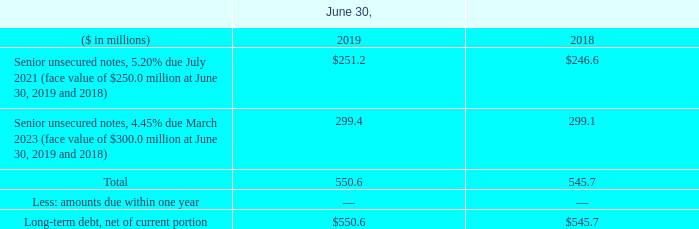10. Debt
On March 31, 2017, the Company entered into a
On March 31, 2017, the Company entered into a $400.0 million syndicated credit facility (“Credit Agreement”) that extends to March 2022. Interest on the borrowings under the Credit Agreement accrue at variable rates, based upon LIBOR or a defined “Base Rate,” both determined based upon the rating of the Company’s senior unsecured long-term debt (the “Debt Rating”). The applicable margin to be added to LIBOR ranges from 1.00% to 1.75% (1.25% as of June 30, 2019), and for Base Rate-determined loans, from 0.00% to 0.75% (0.25% as of June 30, 2019). The Company also pays a quarterly commitment fee ranging from 0.125% to 0.400% (0.20% as of June 30, 2019), determined based upon the Debt Rating, of the unused portion of the $400.0 million commitment under the Credit Agreement. In addition, the Company must pay certain letter of credit fees, ranging from 1.00% to 1.75% (1.25% as of June 30, 2019), with respect to letters of credit issued under the Credit Agreement. The Company has the right to voluntarily prepay and re-borrow loans and to terminate or reduce the commitments under the facility. As of June 30, 2019, the Company had $6.0 million of issued letters of credit under the Credit Agreement and $19.7 million of short-term borrowings, with the balance of $374.3 million available to the Company. As of June 30, 2019, the borrowing rate for the Credit Agreement was 3.90%.
The Company is subject to certain financial and restrictive covenants under the Credit Agreement, which, among other things, require the maintenance of a minimum interest coverage ratio of 3.50 to 1.00. The interest coverage ratio is defined in the Credit Agreement as, for any period, the ratio of consolidated earnings before interest, taxes, depreciation and amortization and non-cash net pension expense (“EBITDA”) to consolidated interest expense for such period. The Credit Agreement also requires the Company to maintain a debt to capital ratio of less than 55 percent. The debt to capital ratio is defined in the Credit Agreement as the ratio of consolidated indebtedness, as defined therein, to consolidated capitalization, as defined therein. As of June 30, 2019, the Company was in compliance with all of the covenants of the Credit Agreement.
Long-term debt outstanding as of June 30, 2019 and 2018 consisted of the following:
Aggregate maturities of long-term debt for the five years subsequent to June 30, 2019, are $0.0 million in fiscal years 2020, 2021, $250.0 million in 2022, $300.0 million in 2023 and $0.0 million in 2024.
For the years ended June 30, 2019, 2018 and 2017, interest costs totaled $31.1 million, $31.1 million and $31.1 million, respectively, of which $5.1 million, $2.8 million and $1.3 million, respectively, were capitalized as part of the cost of property, plant, equipment and software.
What were the interest costs in 2019? $31.1 million. How is the interest coverage ratio defined? The interest coverage ratio is defined in the credit agreement as, for any period, the ratio of consolidated earnings before interest, taxes, depreciation and amortization and non-cash net pension expense (“ebitda”) to consolidated interest expense for such period. In which years was the amount of long-term debt calculated? 2019, 2018. In which year was Total debt larger? 550.6>545.7
Answer: 2019. What was the change in Total debt in 2019 from 2018?
Answer scale should be: million. 550.6-545.7
Answer: 4.9. What was the percentage change in Total debt in 2019 from 2018?
Answer scale should be: percent. (550.6-545.7)/545.7
Answer: 0.9. 